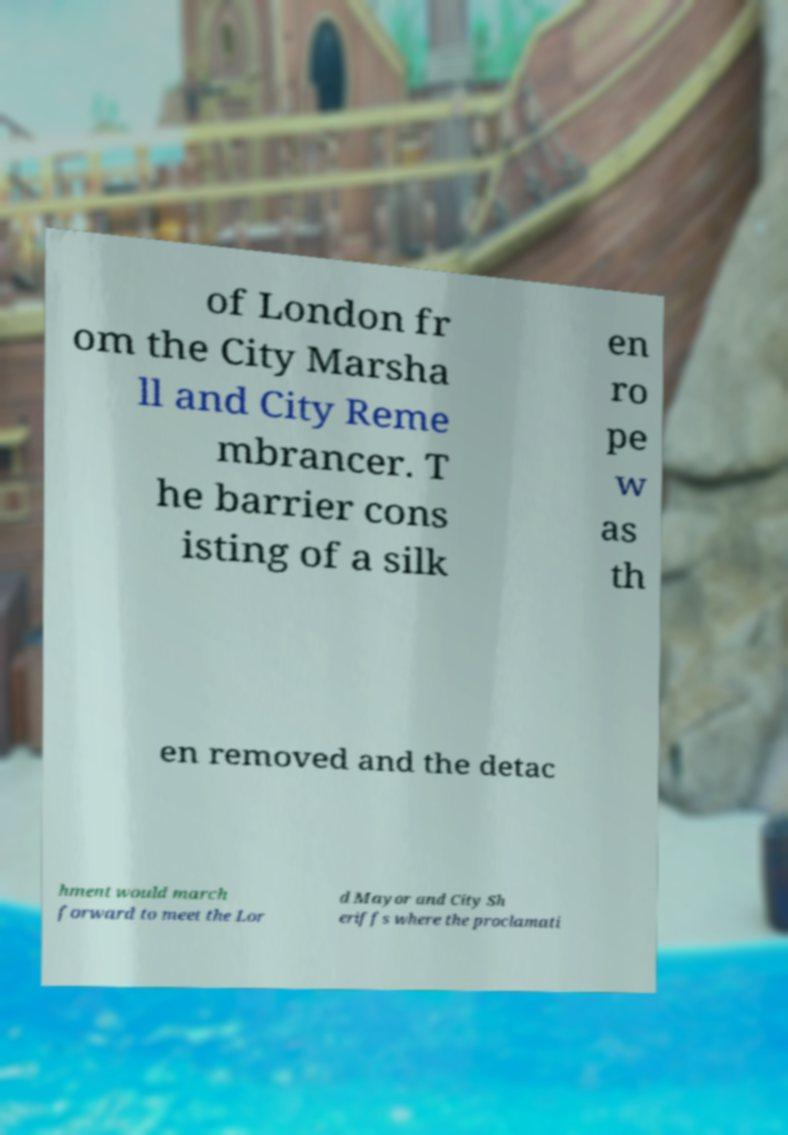Could you assist in decoding the text presented in this image and type it out clearly? of London fr om the City Marsha ll and City Reme mbrancer. T he barrier cons isting of a silk en ro pe w as th en removed and the detac hment would march forward to meet the Lor d Mayor and City Sh eriffs where the proclamati 